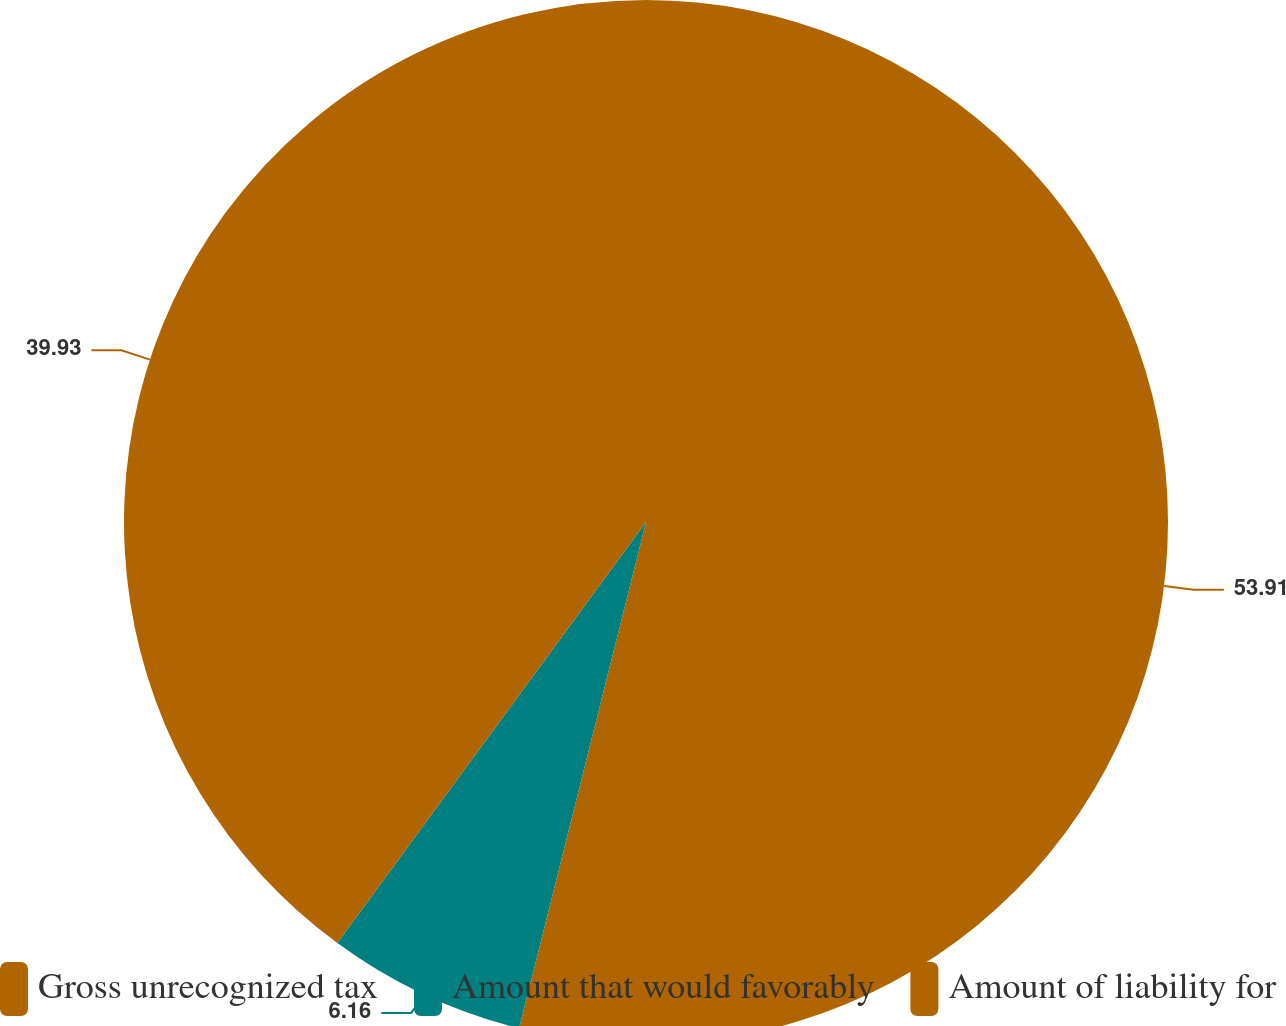Convert chart to OTSL. <chart><loc_0><loc_0><loc_500><loc_500><pie_chart><fcel>Gross unrecognized tax<fcel>Amount that would favorably<fcel>Amount of liability for<nl><fcel>53.91%<fcel>6.16%<fcel>39.93%<nl></chart> 